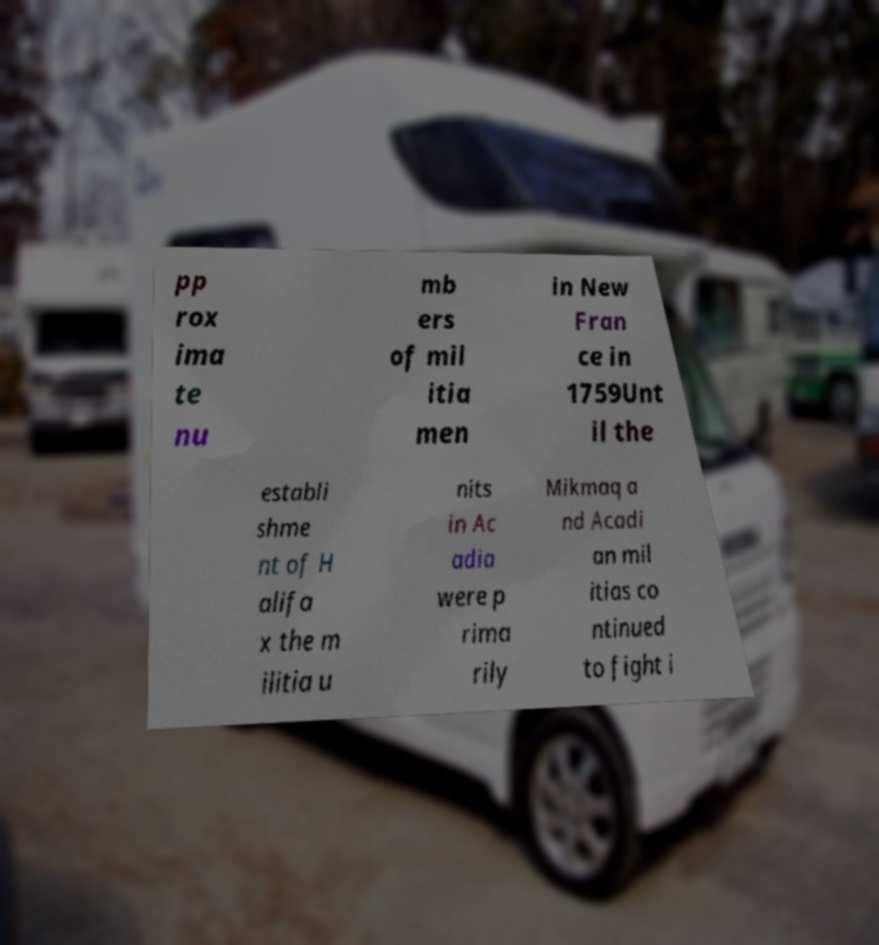Could you extract and type out the text from this image? pp rox ima te nu mb ers of mil itia men in New Fran ce in 1759Unt il the establi shme nt of H alifa x the m ilitia u nits in Ac adia were p rima rily Mikmaq a nd Acadi an mil itias co ntinued to fight i 